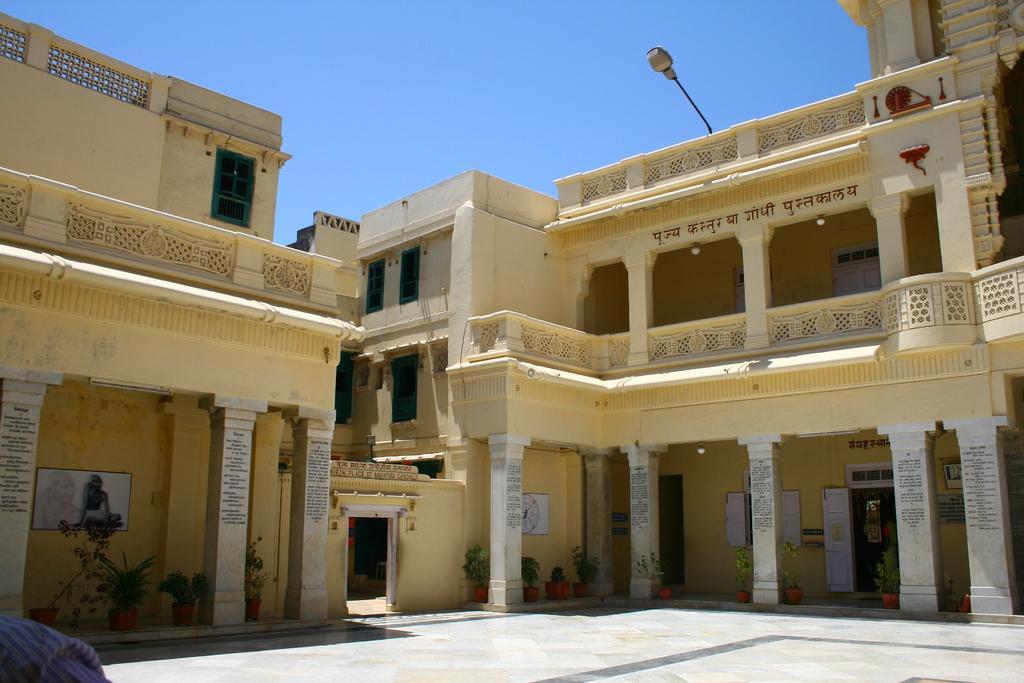Describe this image in one or two sentences. In this image I can see few buildings which are cream in color and few pillars which are white in color. I can see few flower pots with plants in them, the ground and the light. In the background I can see the sky. 